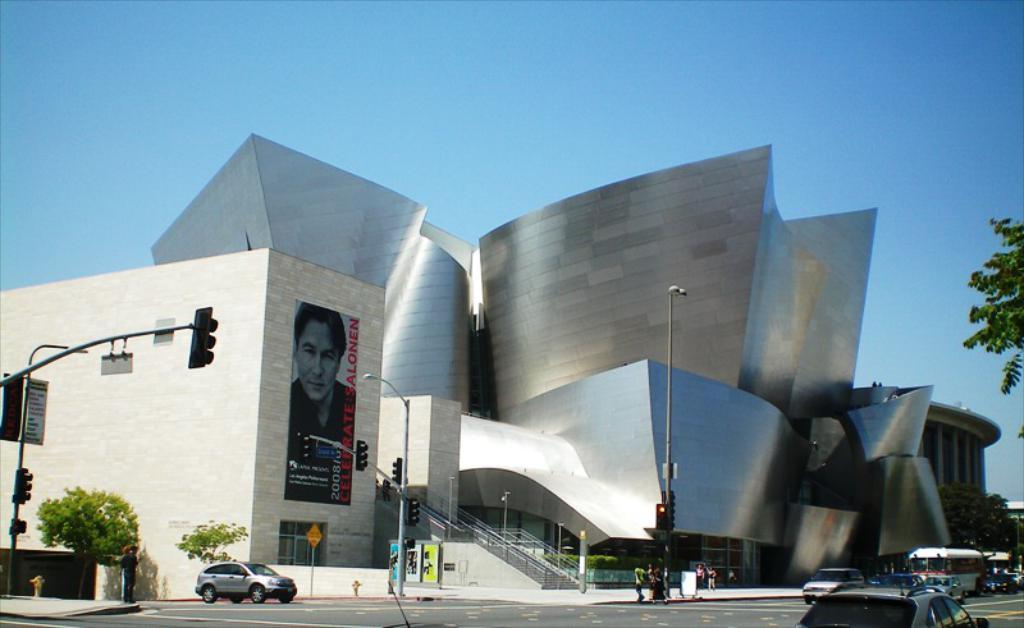What type of structures can be seen in the image? There are buildings in the image. What are the vertical objects in the image? There are poles in the image. What are the illuminating objects in the image? There are lights in the image. What type of vegetation is present in the image? There are plants and trees in the image. Who or what is present in the image? There are people and vehicles in the image. What are the flat, rectangular objects in the image? There are boards in the image. What can be seen in the background of the image? The sky is visible in the background of the image. Can you see a blade of grass sticking out of someone's stocking in the image? There is no blade of grass or stocking present in the image. What color is the crayon that the person is holding in the image? There is no crayon present in the image. 